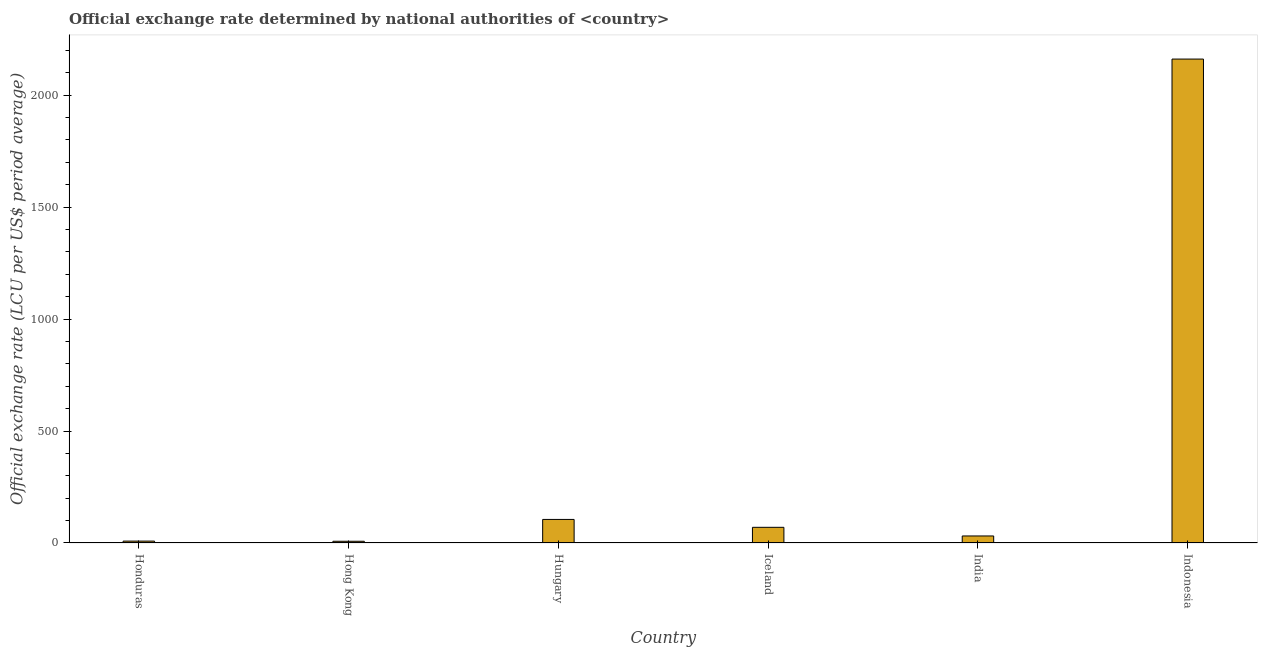Does the graph contain any zero values?
Offer a very short reply. No. What is the title of the graph?
Keep it short and to the point. Official exchange rate determined by national authorities of <country>. What is the label or title of the X-axis?
Keep it short and to the point. Country. What is the label or title of the Y-axis?
Offer a terse response. Official exchange rate (LCU per US$ period average). What is the official exchange rate in Indonesia?
Keep it short and to the point. 2160.75. Across all countries, what is the maximum official exchange rate?
Give a very brief answer. 2160.75. Across all countries, what is the minimum official exchange rate?
Your answer should be very brief. 7.73. In which country was the official exchange rate maximum?
Give a very brief answer. Indonesia. In which country was the official exchange rate minimum?
Offer a very short reply. Hong Kong. What is the sum of the official exchange rate?
Give a very brief answer. 2383.37. What is the difference between the official exchange rate in Hungary and Indonesia?
Provide a short and direct response. -2055.59. What is the average official exchange rate per country?
Your answer should be compact. 397.23. What is the median official exchange rate?
Offer a very short reply. 50.66. In how many countries, is the official exchange rate greater than 1400 ?
Your response must be concise. 1. What is the ratio of the official exchange rate in Honduras to that in Iceland?
Make the answer very short. 0.12. Is the difference between the official exchange rate in Hong Kong and Iceland greater than the difference between any two countries?
Ensure brevity in your answer.  No. What is the difference between the highest and the second highest official exchange rate?
Give a very brief answer. 2055.59. What is the difference between the highest and the lowest official exchange rate?
Provide a short and direct response. 2153.03. How many bars are there?
Give a very brief answer. 6. Are all the bars in the graph horizontal?
Your answer should be very brief. No. What is the difference between two consecutive major ticks on the Y-axis?
Offer a terse response. 500. Are the values on the major ticks of Y-axis written in scientific E-notation?
Provide a short and direct response. No. What is the Official exchange rate (LCU per US$ period average) in Honduras?
Your answer should be very brief. 8.41. What is the Official exchange rate (LCU per US$ period average) in Hong Kong?
Your answer should be very brief. 7.73. What is the Official exchange rate (LCU per US$ period average) in Hungary?
Keep it short and to the point. 105.16. What is the Official exchange rate (LCU per US$ period average) of Iceland?
Your answer should be very brief. 69.94. What is the Official exchange rate (LCU per US$ period average) in India?
Keep it short and to the point. 31.37. What is the Official exchange rate (LCU per US$ period average) of Indonesia?
Your response must be concise. 2160.75. What is the difference between the Official exchange rate (LCU per US$ period average) in Honduras and Hong Kong?
Offer a very short reply. 0.68. What is the difference between the Official exchange rate (LCU per US$ period average) in Honduras and Hungary?
Your answer should be very brief. -96.75. What is the difference between the Official exchange rate (LCU per US$ period average) in Honduras and Iceland?
Your answer should be very brief. -61.54. What is the difference between the Official exchange rate (LCU per US$ period average) in Honduras and India?
Provide a short and direct response. -22.96. What is the difference between the Official exchange rate (LCU per US$ period average) in Honduras and Indonesia?
Give a very brief answer. -2152.34. What is the difference between the Official exchange rate (LCU per US$ period average) in Hong Kong and Hungary?
Make the answer very short. -97.43. What is the difference between the Official exchange rate (LCU per US$ period average) in Hong Kong and Iceland?
Provide a succinct answer. -62.22. What is the difference between the Official exchange rate (LCU per US$ period average) in Hong Kong and India?
Your response must be concise. -23.65. What is the difference between the Official exchange rate (LCU per US$ period average) in Hong Kong and Indonesia?
Keep it short and to the point. -2153.03. What is the difference between the Official exchange rate (LCU per US$ period average) in Hungary and Iceland?
Give a very brief answer. 35.22. What is the difference between the Official exchange rate (LCU per US$ period average) in Hungary and India?
Your answer should be very brief. 73.79. What is the difference between the Official exchange rate (LCU per US$ period average) in Hungary and Indonesia?
Make the answer very short. -2055.59. What is the difference between the Official exchange rate (LCU per US$ period average) in Iceland and India?
Give a very brief answer. 38.57. What is the difference between the Official exchange rate (LCU per US$ period average) in Iceland and Indonesia?
Give a very brief answer. -2090.81. What is the difference between the Official exchange rate (LCU per US$ period average) in India and Indonesia?
Offer a terse response. -2129.38. What is the ratio of the Official exchange rate (LCU per US$ period average) in Honduras to that in Hong Kong?
Offer a terse response. 1.09. What is the ratio of the Official exchange rate (LCU per US$ period average) in Honduras to that in Hungary?
Your response must be concise. 0.08. What is the ratio of the Official exchange rate (LCU per US$ period average) in Honduras to that in Iceland?
Offer a very short reply. 0.12. What is the ratio of the Official exchange rate (LCU per US$ period average) in Honduras to that in India?
Your answer should be compact. 0.27. What is the ratio of the Official exchange rate (LCU per US$ period average) in Honduras to that in Indonesia?
Offer a very short reply. 0. What is the ratio of the Official exchange rate (LCU per US$ period average) in Hong Kong to that in Hungary?
Your answer should be very brief. 0.07. What is the ratio of the Official exchange rate (LCU per US$ period average) in Hong Kong to that in Iceland?
Offer a terse response. 0.11. What is the ratio of the Official exchange rate (LCU per US$ period average) in Hong Kong to that in India?
Your answer should be very brief. 0.25. What is the ratio of the Official exchange rate (LCU per US$ period average) in Hong Kong to that in Indonesia?
Provide a succinct answer. 0. What is the ratio of the Official exchange rate (LCU per US$ period average) in Hungary to that in Iceland?
Give a very brief answer. 1.5. What is the ratio of the Official exchange rate (LCU per US$ period average) in Hungary to that in India?
Offer a very short reply. 3.35. What is the ratio of the Official exchange rate (LCU per US$ period average) in Hungary to that in Indonesia?
Your response must be concise. 0.05. What is the ratio of the Official exchange rate (LCU per US$ period average) in Iceland to that in India?
Your response must be concise. 2.23. What is the ratio of the Official exchange rate (LCU per US$ period average) in Iceland to that in Indonesia?
Ensure brevity in your answer.  0.03. What is the ratio of the Official exchange rate (LCU per US$ period average) in India to that in Indonesia?
Your answer should be compact. 0.01. 